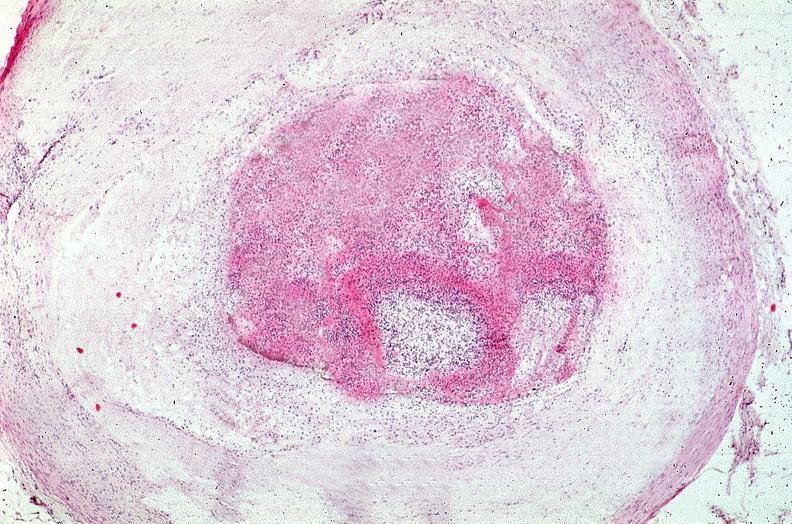how does this image show coronary artery?
Answer the question using a single word or phrase. With atherosclerosis and thrombotic occlusion 